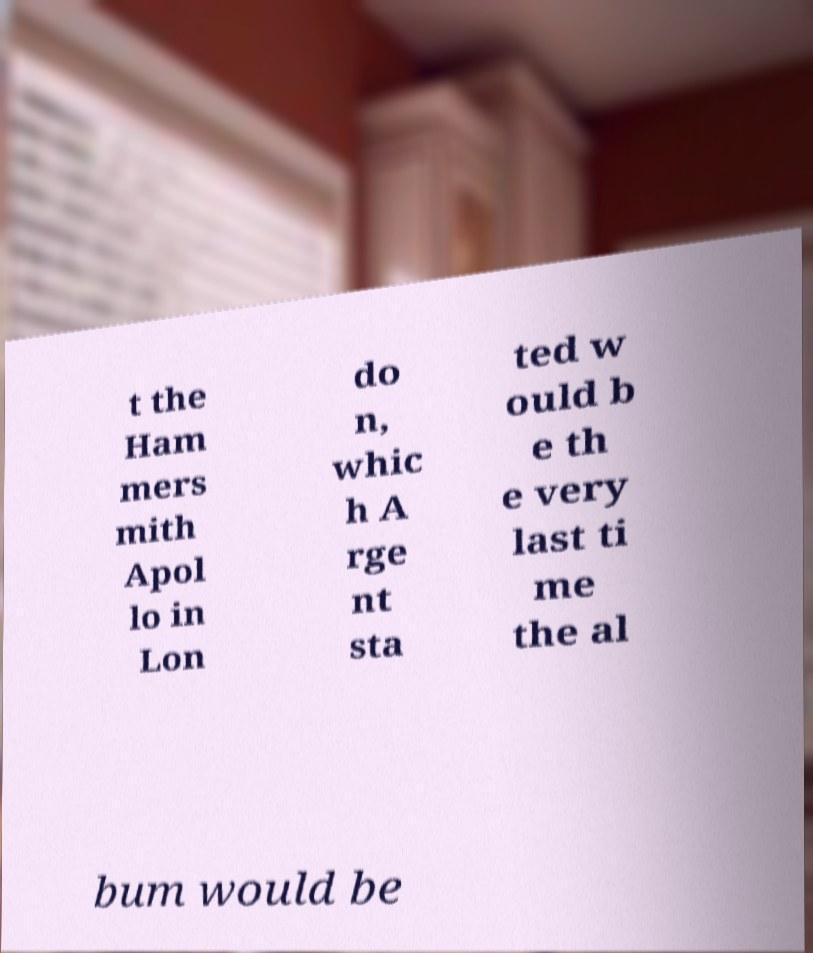Could you extract and type out the text from this image? t the Ham mers mith Apol lo in Lon do n, whic h A rge nt sta ted w ould b e th e very last ti me the al bum would be 